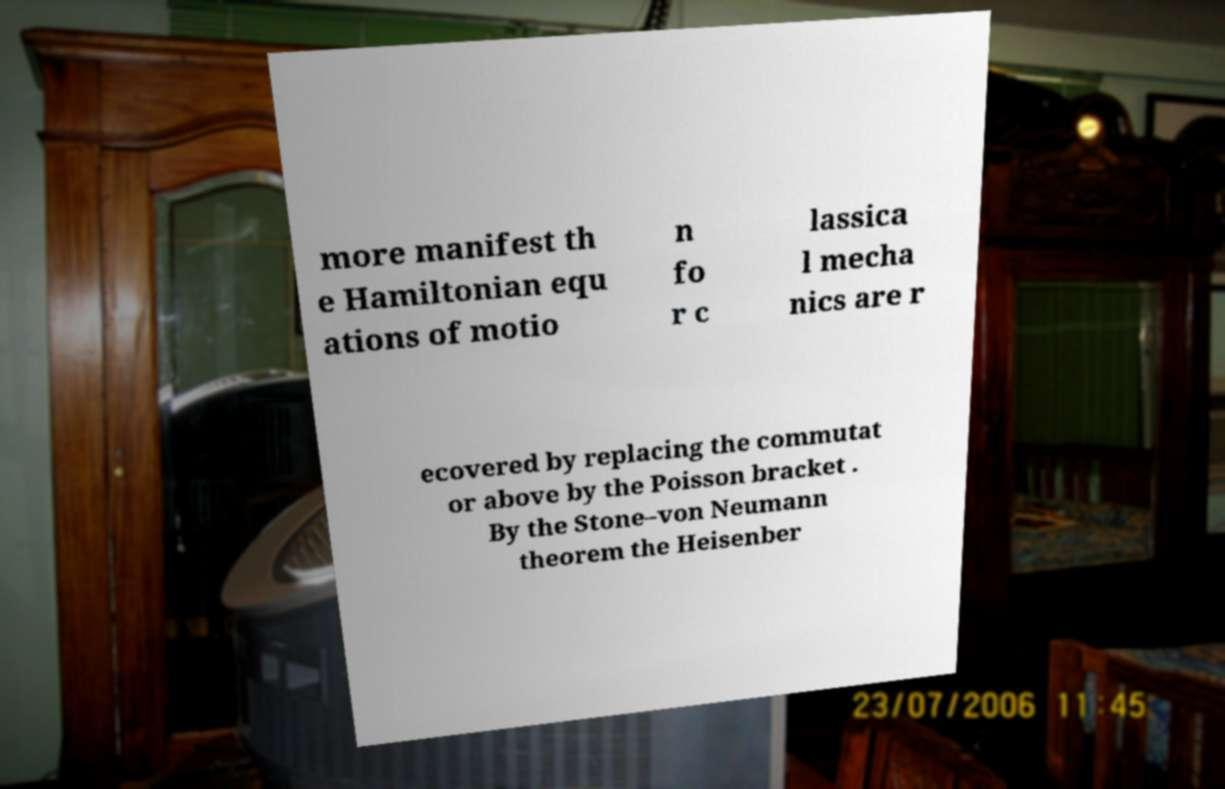Can you read and provide the text displayed in the image?This photo seems to have some interesting text. Can you extract and type it out for me? more manifest th e Hamiltonian equ ations of motio n fo r c lassica l mecha nics are r ecovered by replacing the commutat or above by the Poisson bracket . By the Stone–von Neumann theorem the Heisenber 